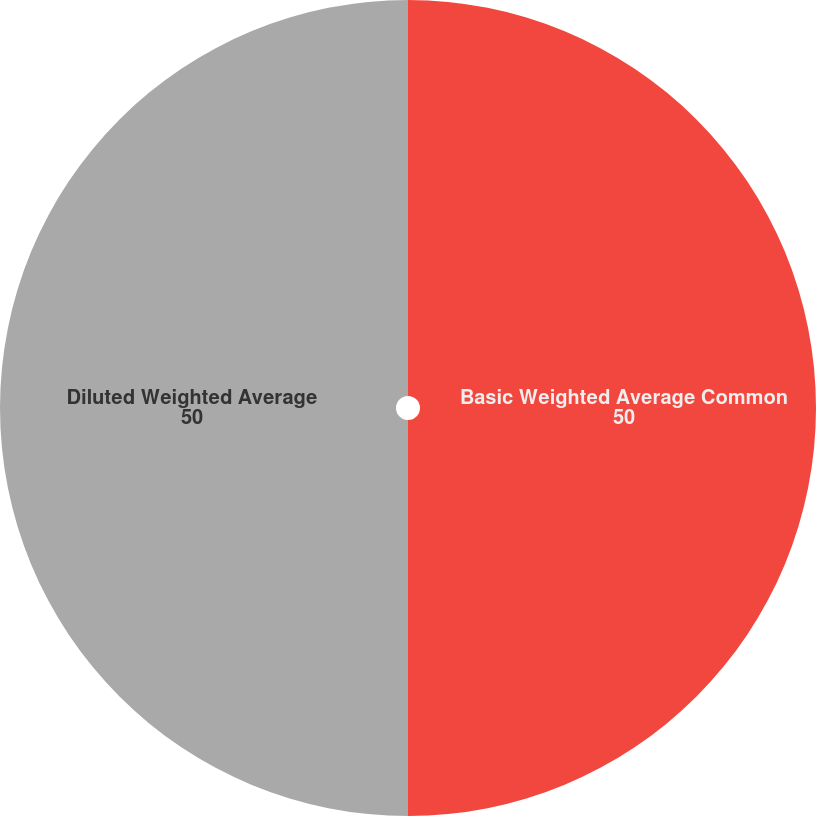Convert chart to OTSL. <chart><loc_0><loc_0><loc_500><loc_500><pie_chart><fcel>Basic Weighted Average Common<fcel>Diluted Weighted Average<nl><fcel>50.0%<fcel>50.0%<nl></chart> 